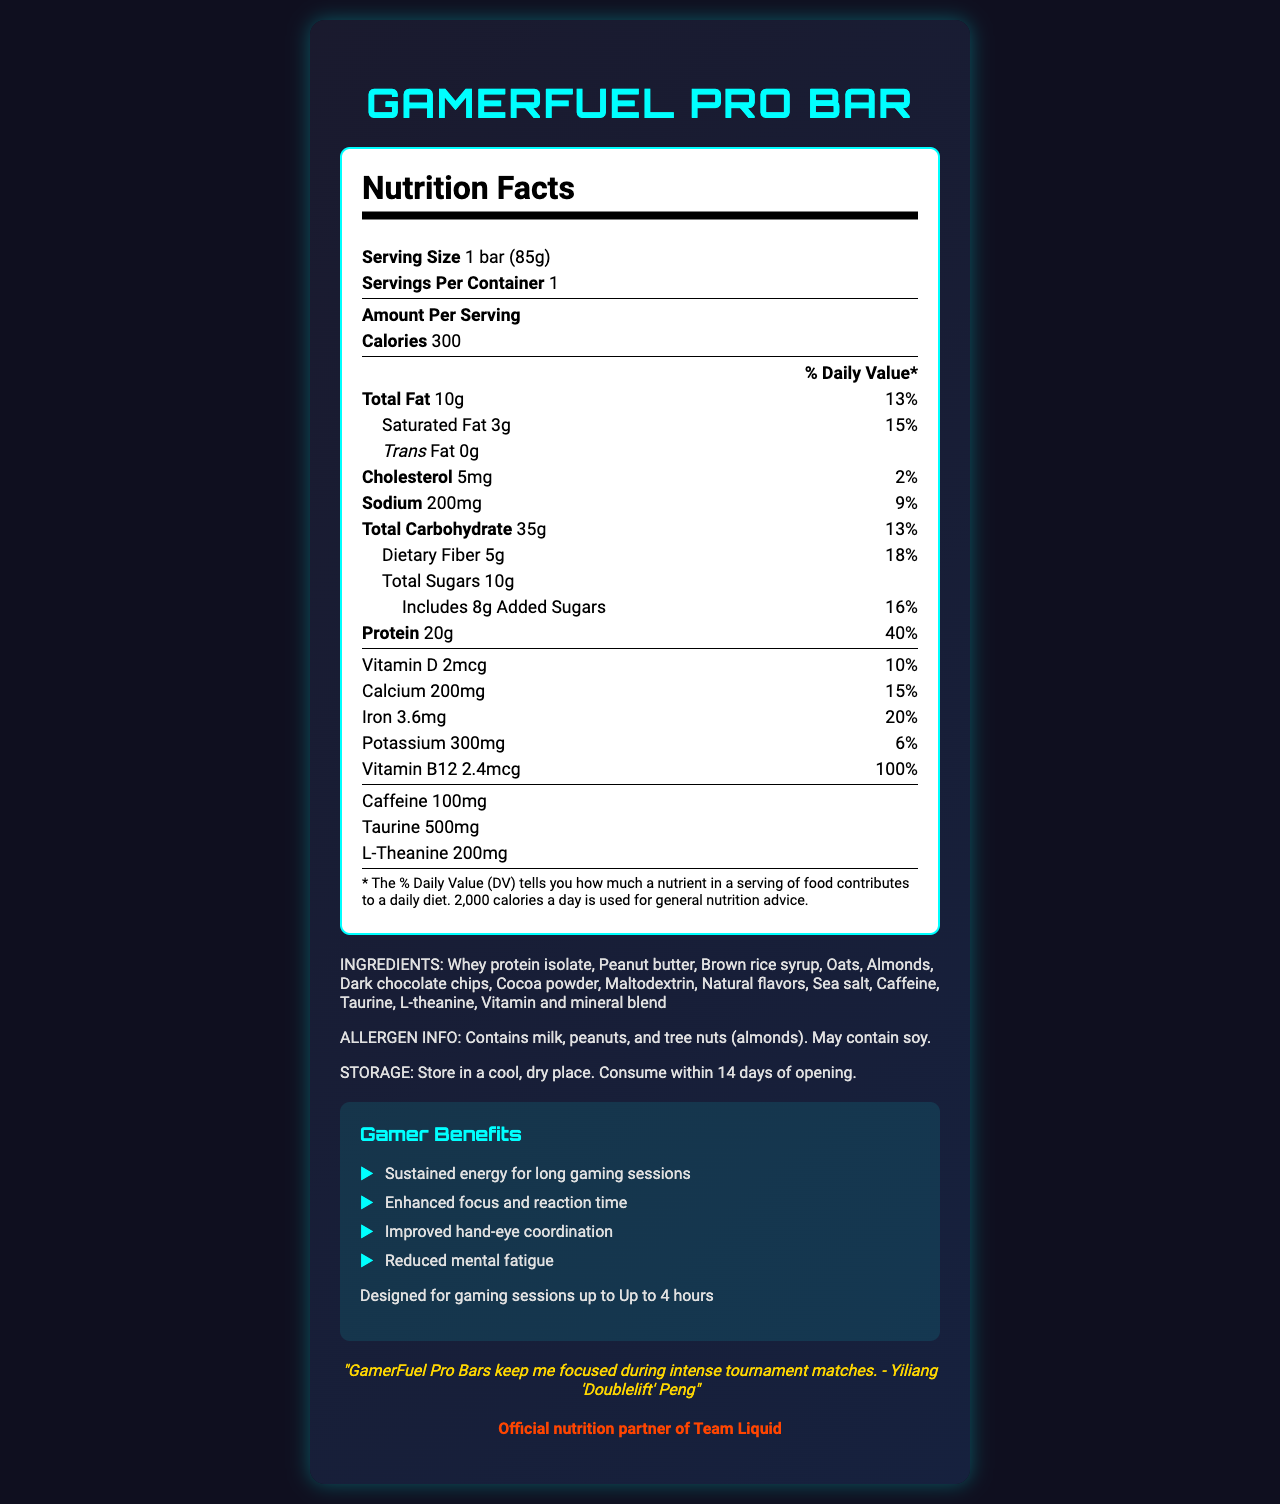who is endorsing the GamerFuel Pro Bar? The document includes a quote from Yiliang 'Doublelift' Peng endorsing the GamerFuel Pro Bar, saying it keeps him focused during tournament matches.
Answer: Yiliang 'Doublelift' Peng What is the serving size of the GamerFuel Pro Bar? The serving size mentioned in the document is 1 bar (85g).
Answer: 1 bar (85g) How many grams of protein are in a single serving? The document states that there are 20g of protein per serving.
Answer: 20g What is the suggested storage method for the bar? The storage instructions mentioned in the document are to store in a cool, dry place and consume within 14 days of opening.
Answer: Store in a cool, dry place. Consume within 14 days of opening. What are the total carbohydrates in a bar? The total carbohydrate amount given in the document is 35g per serving.
Answer: 35g Which of the following allergens are contained in the GamerFuel Pro Bar? A. Wheat B. Milk C. Soy D. Eggs According to the allergen info, the bar contains milk, peanuts, and tree nuts (almonds) and may contain soy.
Answer: B How much Vitamin B12 does the bar provide per serving? A. 2mcg B. 2.4mcg C. 15mcg D. 200mg The document indicates that each serving contains 2.4mcg of Vitamin B12.
Answer: B Is there any trans fat in the GamerFuel Pro Bar? The document indicates that there are 0g of trans fat in the bar.
Answer: No Summarize the main benefits of the GamerFuel Pro Bar The summary includes the major benefits listed in the document, such as energy sustainability, focus enhancement, and essential nutrients, along with its intended use duration.
Answer: The GamerFuel Pro Bar provides sustained energy, enhanced focus, improved hand-eye coordination, and reduced mental fatigue, making it suitable for up to 4-hour gaming sessions. It also has high protein content and essential nutrients to support gamers. How does the GamerFuel Pro Bar support long gaming sessions? The document explains that the bar offers these benefits to support long gaming sessions, making it ideal for gamers.
Answer: It provides sustained energy, enhanced focus, improved hand-eye coordination, and reduced mental fatigue. What is the daily value percentage of calcium in one serving of the bar? The document states that one serving provides 15% of the daily value for calcium.
Answer: 15% What is the caffeine content in the GamerFuel Pro Bar? The document mentions that each bar contains 100mg of caffeine.
Answer: 100mg Name two ingredients found in the GamerFuel Pro Bar that might help in boosting focus. These ingredients are commonly known for their cognitive enhancement properties, which support focus and alertness.
Answer: Caffeine and L-theanine What esports team is partnered with this product? The document mentions that the GamerFuel Pro Bar is the official nutrition partner of Team Liquid.
Answer: Team Liquid What is the highest daily value percentage nutrient in the GamerFuel Pro Bar? The document indicates that protein has the highest daily value percentage at 40%.
Answer: Protein at 40% Can we determine the exact price of the GamerFuel Pro Bar from the document? The document does not provide any information about the price of the bar.
Answer: Cannot be determined How much cardy fiber is included per bar? The dietary fiber content is stated as 5g per serving in the document.
Answer: 5g 